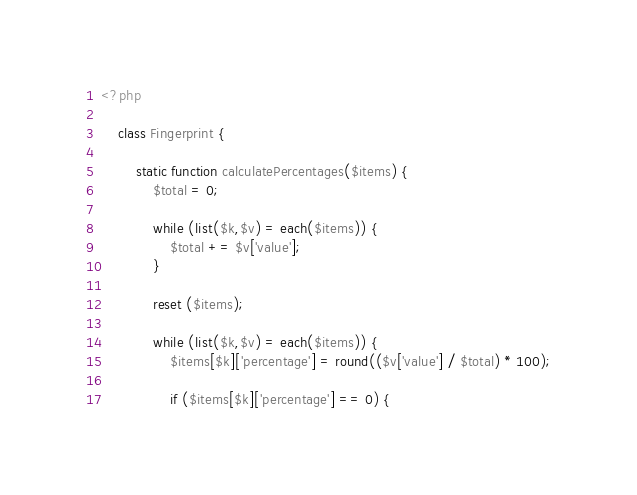<code> <loc_0><loc_0><loc_500><loc_500><_PHP_><?php

	class Fingerprint {

		static function calculatePercentages($items) {
			$total = 0;

			while (list($k,$v) = each($items)) {
				$total += $v['value'];
			}

			reset ($items);

			while (list($k,$v) = each($items)) {
				$items[$k]['percentage'] = round(($v['value'] / $total) * 100);

				if ($items[$k]['percentage'] == 0) {</code> 